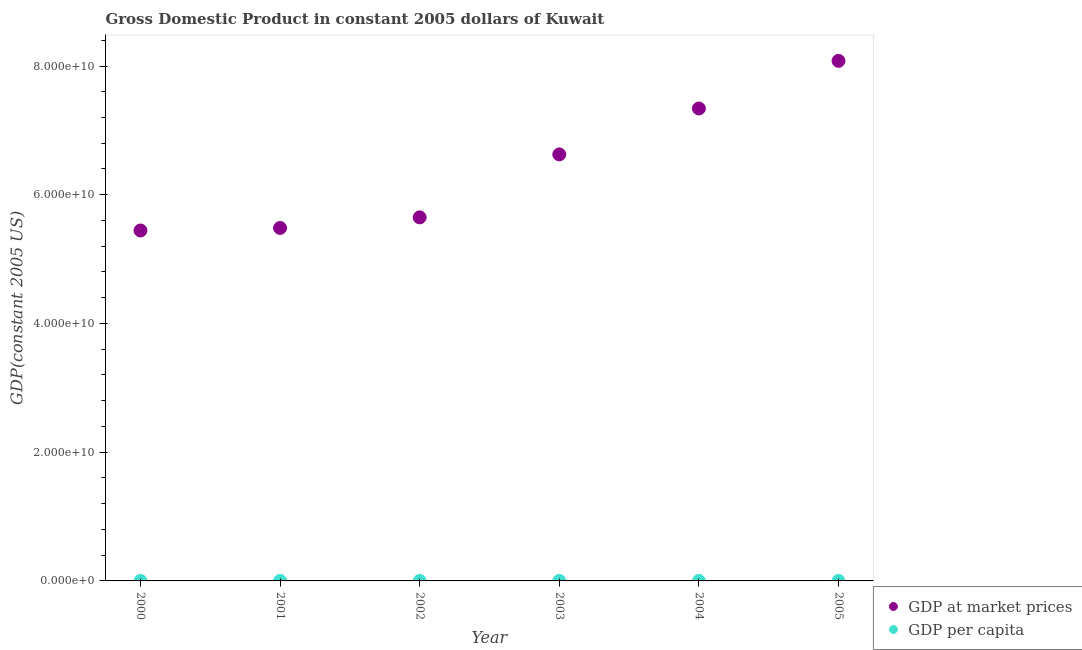What is the gdp per capita in 2004?
Provide a succinct answer. 3.63e+04. Across all years, what is the maximum gdp at market prices?
Your response must be concise. 8.08e+1. Across all years, what is the minimum gdp at market prices?
Give a very brief answer. 5.44e+1. In which year was the gdp per capita maximum?
Offer a very short reply. 2003. What is the total gdp at market prices in the graph?
Offer a terse response. 3.86e+11. What is the difference between the gdp per capita in 2000 and that in 2001?
Your answer should be very brief. -2265.47. What is the difference between the gdp at market prices in 2003 and the gdp per capita in 2002?
Offer a very short reply. 6.63e+1. What is the average gdp at market prices per year?
Make the answer very short. 6.44e+1. In the year 2000, what is the difference between the gdp per capita and gdp at market prices?
Provide a short and direct response. -5.44e+1. What is the ratio of the gdp at market prices in 2000 to that in 2004?
Your answer should be compact. 0.74. What is the difference between the highest and the second highest gdp at market prices?
Offer a terse response. 7.40e+09. What is the difference between the highest and the lowest gdp per capita?
Provide a succinct answer. 4739.23. In how many years, is the gdp per capita greater than the average gdp per capita taken over all years?
Keep it short and to the point. 4. Is the sum of the gdp per capita in 2003 and 2005 greater than the maximum gdp at market prices across all years?
Provide a short and direct response. No. How many dotlines are there?
Your response must be concise. 2. How many years are there in the graph?
Ensure brevity in your answer.  6. Does the graph contain any zero values?
Your answer should be compact. No. Where does the legend appear in the graph?
Offer a terse response. Bottom right. What is the title of the graph?
Your response must be concise. Gross Domestic Product in constant 2005 dollars of Kuwait. Does "Mobile cellular" appear as one of the legend labels in the graph?
Ensure brevity in your answer.  No. What is the label or title of the Y-axis?
Provide a succinct answer. GDP(constant 2005 US). What is the GDP(constant 2005 US) of GDP at market prices in 2000?
Your answer should be very brief. 5.44e+1. What is the GDP(constant 2005 US) in GDP per capita in 2000?
Provide a short and direct response. 3.16e+04. What is the GDP(constant 2005 US) of GDP at market prices in 2001?
Give a very brief answer. 5.48e+1. What is the GDP(constant 2005 US) of GDP per capita in 2001?
Keep it short and to the point. 3.39e+04. What is the GDP(constant 2005 US) of GDP at market prices in 2002?
Your answer should be compact. 5.65e+1. What is the GDP(constant 2005 US) in GDP per capita in 2002?
Ensure brevity in your answer.  3.57e+04. What is the GDP(constant 2005 US) of GDP at market prices in 2003?
Your answer should be compact. 6.63e+1. What is the GDP(constant 2005 US) of GDP per capita in 2003?
Provide a short and direct response. 3.64e+04. What is the GDP(constant 2005 US) of GDP at market prices in 2004?
Offer a terse response. 7.34e+1. What is the GDP(constant 2005 US) of GDP per capita in 2004?
Your answer should be very brief. 3.63e+04. What is the GDP(constant 2005 US) of GDP at market prices in 2005?
Keep it short and to the point. 8.08e+1. What is the GDP(constant 2005 US) in GDP per capita in 2005?
Give a very brief answer. 3.49e+04. Across all years, what is the maximum GDP(constant 2005 US) in GDP at market prices?
Keep it short and to the point. 8.08e+1. Across all years, what is the maximum GDP(constant 2005 US) in GDP per capita?
Offer a very short reply. 3.64e+04. Across all years, what is the minimum GDP(constant 2005 US) in GDP at market prices?
Provide a short and direct response. 5.44e+1. Across all years, what is the minimum GDP(constant 2005 US) of GDP per capita?
Provide a short and direct response. 3.16e+04. What is the total GDP(constant 2005 US) in GDP at market prices in the graph?
Provide a short and direct response. 3.86e+11. What is the total GDP(constant 2005 US) in GDP per capita in the graph?
Your answer should be very brief. 2.09e+05. What is the difference between the GDP(constant 2005 US) of GDP at market prices in 2000 and that in 2001?
Provide a succinct answer. -3.97e+08. What is the difference between the GDP(constant 2005 US) of GDP per capita in 2000 and that in 2001?
Keep it short and to the point. -2265.47. What is the difference between the GDP(constant 2005 US) in GDP at market prices in 2000 and that in 2002?
Your answer should be compact. -2.04e+09. What is the difference between the GDP(constant 2005 US) of GDP per capita in 2000 and that in 2002?
Provide a succinct answer. -4076.96. What is the difference between the GDP(constant 2005 US) of GDP at market prices in 2000 and that in 2003?
Provide a short and direct response. -1.18e+1. What is the difference between the GDP(constant 2005 US) of GDP per capita in 2000 and that in 2003?
Give a very brief answer. -4739.23. What is the difference between the GDP(constant 2005 US) in GDP at market prices in 2000 and that in 2004?
Provide a short and direct response. -1.90e+1. What is the difference between the GDP(constant 2005 US) of GDP per capita in 2000 and that in 2004?
Ensure brevity in your answer.  -4654.41. What is the difference between the GDP(constant 2005 US) of GDP at market prices in 2000 and that in 2005?
Your response must be concise. -2.64e+1. What is the difference between the GDP(constant 2005 US) of GDP per capita in 2000 and that in 2005?
Make the answer very short. -3263.41. What is the difference between the GDP(constant 2005 US) in GDP at market prices in 2001 and that in 2002?
Provide a succinct answer. -1.65e+09. What is the difference between the GDP(constant 2005 US) in GDP per capita in 2001 and that in 2002?
Provide a succinct answer. -1811.49. What is the difference between the GDP(constant 2005 US) in GDP at market prices in 2001 and that in 2003?
Keep it short and to the point. -1.14e+1. What is the difference between the GDP(constant 2005 US) of GDP per capita in 2001 and that in 2003?
Your answer should be very brief. -2473.76. What is the difference between the GDP(constant 2005 US) of GDP at market prices in 2001 and that in 2004?
Give a very brief answer. -1.86e+1. What is the difference between the GDP(constant 2005 US) of GDP per capita in 2001 and that in 2004?
Offer a very short reply. -2388.95. What is the difference between the GDP(constant 2005 US) in GDP at market prices in 2001 and that in 2005?
Ensure brevity in your answer.  -2.60e+1. What is the difference between the GDP(constant 2005 US) of GDP per capita in 2001 and that in 2005?
Give a very brief answer. -997.95. What is the difference between the GDP(constant 2005 US) of GDP at market prices in 2002 and that in 2003?
Ensure brevity in your answer.  -9.78e+09. What is the difference between the GDP(constant 2005 US) in GDP per capita in 2002 and that in 2003?
Keep it short and to the point. -662.27. What is the difference between the GDP(constant 2005 US) of GDP at market prices in 2002 and that in 2004?
Provide a succinct answer. -1.69e+1. What is the difference between the GDP(constant 2005 US) in GDP per capita in 2002 and that in 2004?
Make the answer very short. -577.45. What is the difference between the GDP(constant 2005 US) in GDP at market prices in 2002 and that in 2005?
Ensure brevity in your answer.  -2.43e+1. What is the difference between the GDP(constant 2005 US) in GDP per capita in 2002 and that in 2005?
Keep it short and to the point. 813.54. What is the difference between the GDP(constant 2005 US) in GDP at market prices in 2003 and that in 2004?
Your answer should be compact. -7.13e+09. What is the difference between the GDP(constant 2005 US) of GDP per capita in 2003 and that in 2004?
Provide a short and direct response. 84.82. What is the difference between the GDP(constant 2005 US) of GDP at market prices in 2003 and that in 2005?
Provide a short and direct response. -1.45e+1. What is the difference between the GDP(constant 2005 US) of GDP per capita in 2003 and that in 2005?
Keep it short and to the point. 1475.82. What is the difference between the GDP(constant 2005 US) in GDP at market prices in 2004 and that in 2005?
Your answer should be very brief. -7.40e+09. What is the difference between the GDP(constant 2005 US) in GDP per capita in 2004 and that in 2005?
Give a very brief answer. 1391. What is the difference between the GDP(constant 2005 US) in GDP at market prices in 2000 and the GDP(constant 2005 US) in GDP per capita in 2001?
Your answer should be compact. 5.44e+1. What is the difference between the GDP(constant 2005 US) in GDP at market prices in 2000 and the GDP(constant 2005 US) in GDP per capita in 2002?
Ensure brevity in your answer.  5.44e+1. What is the difference between the GDP(constant 2005 US) of GDP at market prices in 2000 and the GDP(constant 2005 US) of GDP per capita in 2003?
Make the answer very short. 5.44e+1. What is the difference between the GDP(constant 2005 US) in GDP at market prices in 2000 and the GDP(constant 2005 US) in GDP per capita in 2004?
Provide a succinct answer. 5.44e+1. What is the difference between the GDP(constant 2005 US) in GDP at market prices in 2000 and the GDP(constant 2005 US) in GDP per capita in 2005?
Offer a very short reply. 5.44e+1. What is the difference between the GDP(constant 2005 US) in GDP at market prices in 2001 and the GDP(constant 2005 US) in GDP per capita in 2002?
Provide a short and direct response. 5.48e+1. What is the difference between the GDP(constant 2005 US) of GDP at market prices in 2001 and the GDP(constant 2005 US) of GDP per capita in 2003?
Keep it short and to the point. 5.48e+1. What is the difference between the GDP(constant 2005 US) of GDP at market prices in 2001 and the GDP(constant 2005 US) of GDP per capita in 2004?
Offer a terse response. 5.48e+1. What is the difference between the GDP(constant 2005 US) of GDP at market prices in 2001 and the GDP(constant 2005 US) of GDP per capita in 2005?
Your response must be concise. 5.48e+1. What is the difference between the GDP(constant 2005 US) in GDP at market prices in 2002 and the GDP(constant 2005 US) in GDP per capita in 2003?
Your answer should be compact. 5.65e+1. What is the difference between the GDP(constant 2005 US) of GDP at market prices in 2002 and the GDP(constant 2005 US) of GDP per capita in 2004?
Offer a terse response. 5.65e+1. What is the difference between the GDP(constant 2005 US) of GDP at market prices in 2002 and the GDP(constant 2005 US) of GDP per capita in 2005?
Ensure brevity in your answer.  5.65e+1. What is the difference between the GDP(constant 2005 US) in GDP at market prices in 2003 and the GDP(constant 2005 US) in GDP per capita in 2004?
Provide a succinct answer. 6.63e+1. What is the difference between the GDP(constant 2005 US) of GDP at market prices in 2003 and the GDP(constant 2005 US) of GDP per capita in 2005?
Your answer should be compact. 6.63e+1. What is the difference between the GDP(constant 2005 US) in GDP at market prices in 2004 and the GDP(constant 2005 US) in GDP per capita in 2005?
Provide a succinct answer. 7.34e+1. What is the average GDP(constant 2005 US) of GDP at market prices per year?
Your answer should be very brief. 6.44e+1. What is the average GDP(constant 2005 US) in GDP per capita per year?
Keep it short and to the point. 3.48e+04. In the year 2000, what is the difference between the GDP(constant 2005 US) of GDP at market prices and GDP(constant 2005 US) of GDP per capita?
Your answer should be very brief. 5.44e+1. In the year 2001, what is the difference between the GDP(constant 2005 US) of GDP at market prices and GDP(constant 2005 US) of GDP per capita?
Offer a terse response. 5.48e+1. In the year 2002, what is the difference between the GDP(constant 2005 US) in GDP at market prices and GDP(constant 2005 US) in GDP per capita?
Make the answer very short. 5.65e+1. In the year 2003, what is the difference between the GDP(constant 2005 US) in GDP at market prices and GDP(constant 2005 US) in GDP per capita?
Offer a terse response. 6.63e+1. In the year 2004, what is the difference between the GDP(constant 2005 US) of GDP at market prices and GDP(constant 2005 US) of GDP per capita?
Offer a very short reply. 7.34e+1. In the year 2005, what is the difference between the GDP(constant 2005 US) in GDP at market prices and GDP(constant 2005 US) in GDP per capita?
Your response must be concise. 8.08e+1. What is the ratio of the GDP(constant 2005 US) in GDP per capita in 2000 to that in 2001?
Your response must be concise. 0.93. What is the ratio of the GDP(constant 2005 US) in GDP at market prices in 2000 to that in 2002?
Offer a very short reply. 0.96. What is the ratio of the GDP(constant 2005 US) of GDP per capita in 2000 to that in 2002?
Ensure brevity in your answer.  0.89. What is the ratio of the GDP(constant 2005 US) of GDP at market prices in 2000 to that in 2003?
Offer a terse response. 0.82. What is the ratio of the GDP(constant 2005 US) in GDP per capita in 2000 to that in 2003?
Provide a succinct answer. 0.87. What is the ratio of the GDP(constant 2005 US) in GDP at market prices in 2000 to that in 2004?
Your answer should be compact. 0.74. What is the ratio of the GDP(constant 2005 US) in GDP per capita in 2000 to that in 2004?
Your answer should be compact. 0.87. What is the ratio of the GDP(constant 2005 US) of GDP at market prices in 2000 to that in 2005?
Ensure brevity in your answer.  0.67. What is the ratio of the GDP(constant 2005 US) in GDP per capita in 2000 to that in 2005?
Provide a succinct answer. 0.91. What is the ratio of the GDP(constant 2005 US) in GDP at market prices in 2001 to that in 2002?
Your answer should be compact. 0.97. What is the ratio of the GDP(constant 2005 US) of GDP per capita in 2001 to that in 2002?
Offer a terse response. 0.95. What is the ratio of the GDP(constant 2005 US) in GDP at market prices in 2001 to that in 2003?
Offer a terse response. 0.83. What is the ratio of the GDP(constant 2005 US) of GDP per capita in 2001 to that in 2003?
Your answer should be very brief. 0.93. What is the ratio of the GDP(constant 2005 US) in GDP at market prices in 2001 to that in 2004?
Give a very brief answer. 0.75. What is the ratio of the GDP(constant 2005 US) in GDP per capita in 2001 to that in 2004?
Your answer should be very brief. 0.93. What is the ratio of the GDP(constant 2005 US) in GDP at market prices in 2001 to that in 2005?
Offer a terse response. 0.68. What is the ratio of the GDP(constant 2005 US) in GDP per capita in 2001 to that in 2005?
Offer a very short reply. 0.97. What is the ratio of the GDP(constant 2005 US) of GDP at market prices in 2002 to that in 2003?
Give a very brief answer. 0.85. What is the ratio of the GDP(constant 2005 US) in GDP per capita in 2002 to that in 2003?
Provide a succinct answer. 0.98. What is the ratio of the GDP(constant 2005 US) in GDP at market prices in 2002 to that in 2004?
Your answer should be compact. 0.77. What is the ratio of the GDP(constant 2005 US) in GDP per capita in 2002 to that in 2004?
Provide a succinct answer. 0.98. What is the ratio of the GDP(constant 2005 US) in GDP at market prices in 2002 to that in 2005?
Provide a short and direct response. 0.7. What is the ratio of the GDP(constant 2005 US) of GDP per capita in 2002 to that in 2005?
Offer a terse response. 1.02. What is the ratio of the GDP(constant 2005 US) in GDP at market prices in 2003 to that in 2004?
Provide a succinct answer. 0.9. What is the ratio of the GDP(constant 2005 US) in GDP at market prices in 2003 to that in 2005?
Offer a terse response. 0.82. What is the ratio of the GDP(constant 2005 US) of GDP per capita in 2003 to that in 2005?
Provide a succinct answer. 1.04. What is the ratio of the GDP(constant 2005 US) in GDP at market prices in 2004 to that in 2005?
Keep it short and to the point. 0.91. What is the ratio of the GDP(constant 2005 US) of GDP per capita in 2004 to that in 2005?
Provide a short and direct response. 1.04. What is the difference between the highest and the second highest GDP(constant 2005 US) of GDP at market prices?
Make the answer very short. 7.40e+09. What is the difference between the highest and the second highest GDP(constant 2005 US) of GDP per capita?
Your answer should be very brief. 84.82. What is the difference between the highest and the lowest GDP(constant 2005 US) of GDP at market prices?
Keep it short and to the point. 2.64e+1. What is the difference between the highest and the lowest GDP(constant 2005 US) of GDP per capita?
Give a very brief answer. 4739.23. 